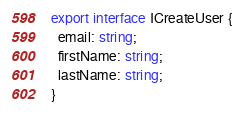Convert code to text. <code><loc_0><loc_0><loc_500><loc_500><_TypeScript_>export interface ICreateUser {
  email: string;
  firstName: string;
  lastName: string;
}</code> 